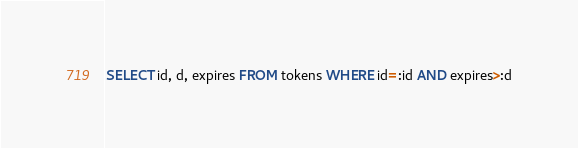Convert code to text. <code><loc_0><loc_0><loc_500><loc_500><_SQL_>SELECT id, d, expires FROM tokens WHERE id=:id AND expires>:d
</code> 